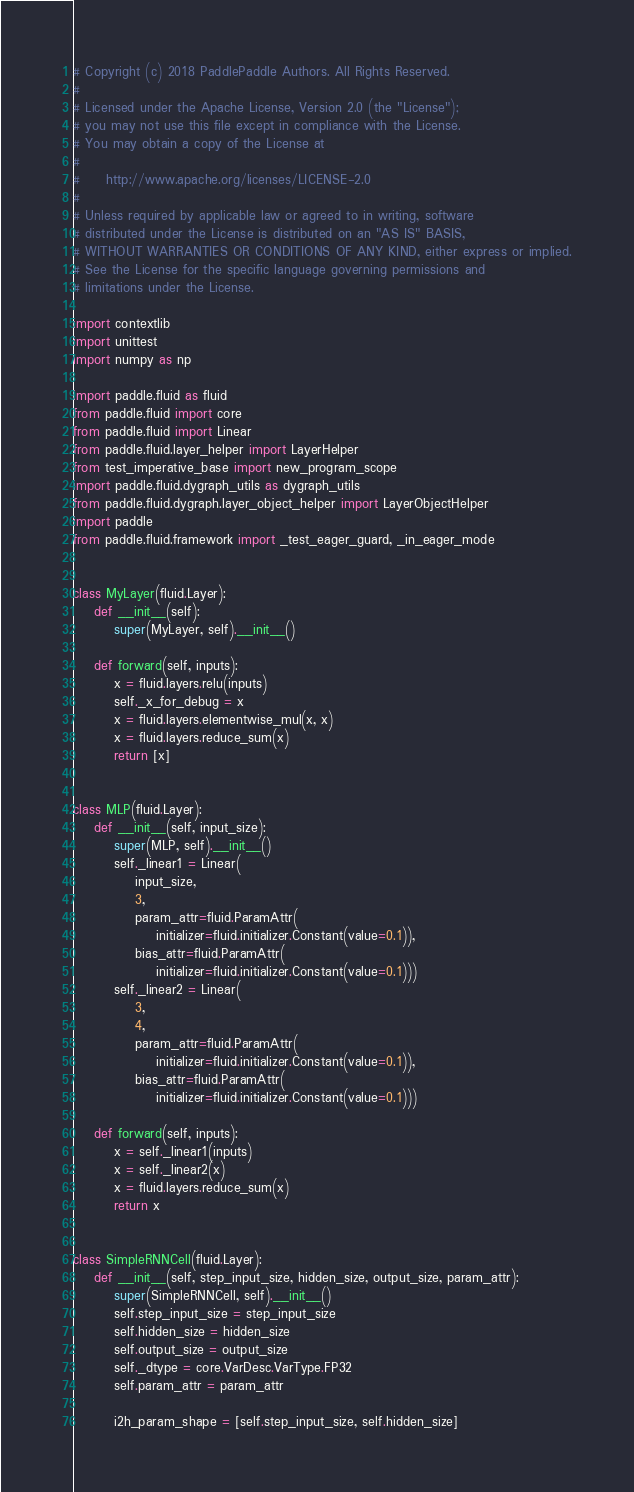Convert code to text. <code><loc_0><loc_0><loc_500><loc_500><_Python_># Copyright (c) 2018 PaddlePaddle Authors. All Rights Reserved.
#
# Licensed under the Apache License, Version 2.0 (the "License");
# you may not use this file except in compliance with the License.
# You may obtain a copy of the License at
#
#     http://www.apache.org/licenses/LICENSE-2.0
#
# Unless required by applicable law or agreed to in writing, software
# distributed under the License is distributed on an "AS IS" BASIS,
# WITHOUT WARRANTIES OR CONDITIONS OF ANY KIND, either express or implied.
# See the License for the specific language governing permissions and
# limitations under the License.

import contextlib
import unittest
import numpy as np

import paddle.fluid as fluid
from paddle.fluid import core
from paddle.fluid import Linear
from paddle.fluid.layer_helper import LayerHelper
from test_imperative_base import new_program_scope
import paddle.fluid.dygraph_utils as dygraph_utils
from paddle.fluid.dygraph.layer_object_helper import LayerObjectHelper
import paddle
from paddle.fluid.framework import _test_eager_guard, _in_eager_mode


class MyLayer(fluid.Layer):
    def __init__(self):
        super(MyLayer, self).__init__()

    def forward(self, inputs):
        x = fluid.layers.relu(inputs)
        self._x_for_debug = x
        x = fluid.layers.elementwise_mul(x, x)
        x = fluid.layers.reduce_sum(x)
        return [x]


class MLP(fluid.Layer):
    def __init__(self, input_size):
        super(MLP, self).__init__()
        self._linear1 = Linear(
            input_size,
            3,
            param_attr=fluid.ParamAttr(
                initializer=fluid.initializer.Constant(value=0.1)),
            bias_attr=fluid.ParamAttr(
                initializer=fluid.initializer.Constant(value=0.1)))
        self._linear2 = Linear(
            3,
            4,
            param_attr=fluid.ParamAttr(
                initializer=fluid.initializer.Constant(value=0.1)),
            bias_attr=fluid.ParamAttr(
                initializer=fluid.initializer.Constant(value=0.1)))

    def forward(self, inputs):
        x = self._linear1(inputs)
        x = self._linear2(x)
        x = fluid.layers.reduce_sum(x)
        return x


class SimpleRNNCell(fluid.Layer):
    def __init__(self, step_input_size, hidden_size, output_size, param_attr):
        super(SimpleRNNCell, self).__init__()
        self.step_input_size = step_input_size
        self.hidden_size = hidden_size
        self.output_size = output_size
        self._dtype = core.VarDesc.VarType.FP32
        self.param_attr = param_attr

        i2h_param_shape = [self.step_input_size, self.hidden_size]</code> 